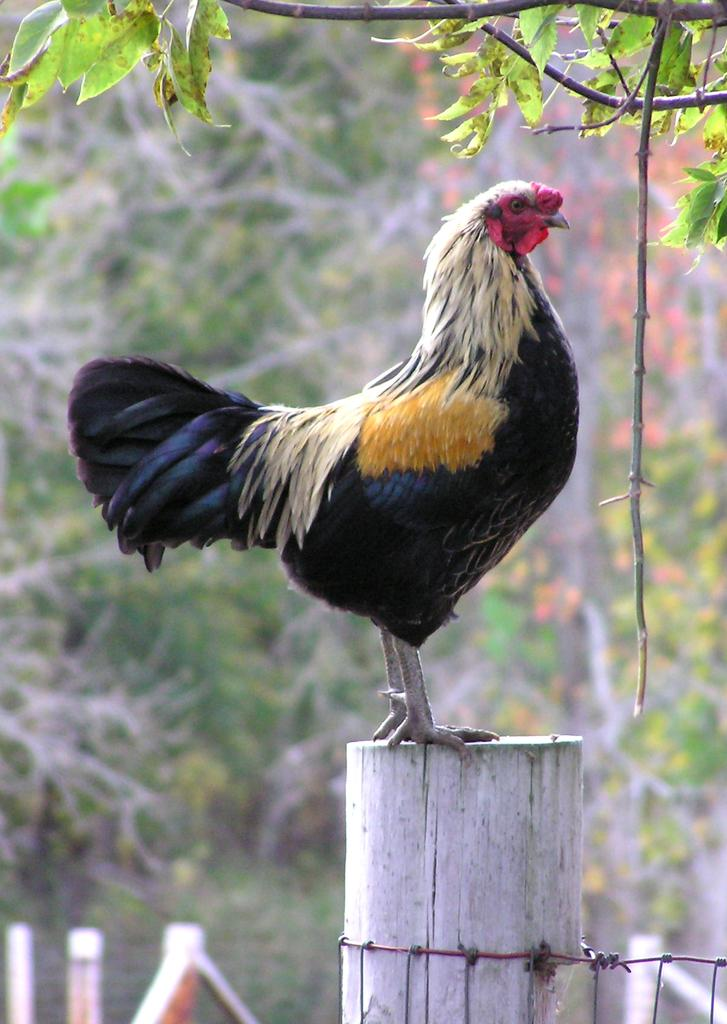What animal can be seen in the image? There is a hen in the image. What is the hen standing on? The hen is standing on a wooden log. What can be seen in the background of the image? There are trees in the background of the image. How would you describe the background in the image? The background is slightly blurred. How many knives are being used by the hen in the image? There are no knives present in the image; the hen is simply standing on a wooden log. 